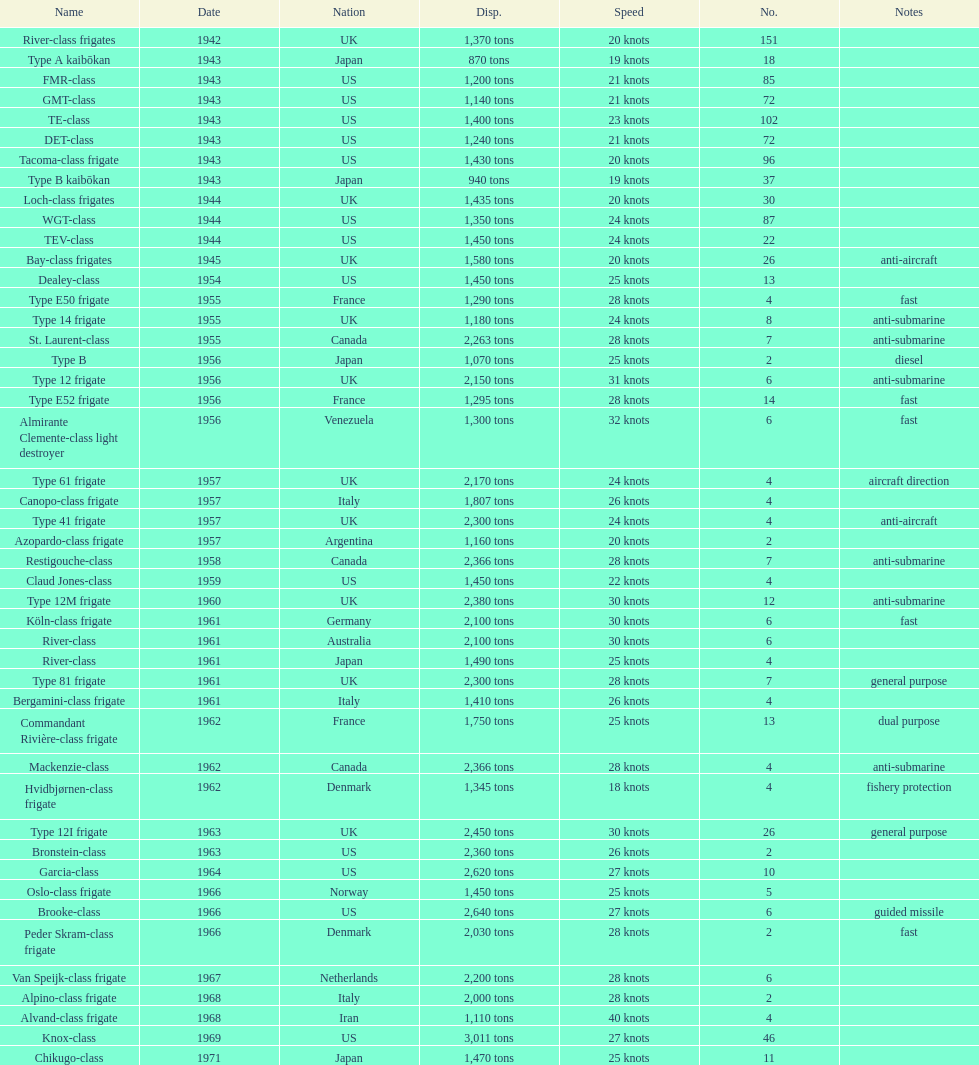Which of the boats listed is the fastest? Alvand-class frigate. Can you give me this table as a dict? {'header': ['Name', 'Date', 'Nation', 'Disp.', 'Speed', 'No.', 'Notes'], 'rows': [['River-class frigates', '1942', 'UK', '1,370 tons', '20 knots', '151', ''], ['Type A kaibōkan', '1943', 'Japan', '870 tons', '19 knots', '18', ''], ['FMR-class', '1943', 'US', '1,200 tons', '21 knots', '85', ''], ['GMT-class', '1943', 'US', '1,140 tons', '21 knots', '72', ''], ['TE-class', '1943', 'US', '1,400 tons', '23 knots', '102', ''], ['DET-class', '1943', 'US', '1,240 tons', '21 knots', '72', ''], ['Tacoma-class frigate', '1943', 'US', '1,430 tons', '20 knots', '96', ''], ['Type B kaibōkan', '1943', 'Japan', '940 tons', '19 knots', '37', ''], ['Loch-class frigates', '1944', 'UK', '1,435 tons', '20 knots', '30', ''], ['WGT-class', '1944', 'US', '1,350 tons', '24 knots', '87', ''], ['TEV-class', '1944', 'US', '1,450 tons', '24 knots', '22', ''], ['Bay-class frigates', '1945', 'UK', '1,580 tons', '20 knots', '26', 'anti-aircraft'], ['Dealey-class', '1954', 'US', '1,450 tons', '25 knots', '13', ''], ['Type E50 frigate', '1955', 'France', '1,290 tons', '28 knots', '4', 'fast'], ['Type 14 frigate', '1955', 'UK', '1,180 tons', '24 knots', '8', 'anti-submarine'], ['St. Laurent-class', '1955', 'Canada', '2,263 tons', '28 knots', '7', 'anti-submarine'], ['Type B', '1956', 'Japan', '1,070 tons', '25 knots', '2', 'diesel'], ['Type 12 frigate', '1956', 'UK', '2,150 tons', '31 knots', '6', 'anti-submarine'], ['Type E52 frigate', '1956', 'France', '1,295 tons', '28 knots', '14', 'fast'], ['Almirante Clemente-class light destroyer', '1956', 'Venezuela', '1,300 tons', '32 knots', '6', 'fast'], ['Type 61 frigate', '1957', 'UK', '2,170 tons', '24 knots', '4', 'aircraft direction'], ['Canopo-class frigate', '1957', 'Italy', '1,807 tons', '26 knots', '4', ''], ['Type 41 frigate', '1957', 'UK', '2,300 tons', '24 knots', '4', 'anti-aircraft'], ['Azopardo-class frigate', '1957', 'Argentina', '1,160 tons', '20 knots', '2', ''], ['Restigouche-class', '1958', 'Canada', '2,366 tons', '28 knots', '7', 'anti-submarine'], ['Claud Jones-class', '1959', 'US', '1,450 tons', '22 knots', '4', ''], ['Type 12M frigate', '1960', 'UK', '2,380 tons', '30 knots', '12', 'anti-submarine'], ['Köln-class frigate', '1961', 'Germany', '2,100 tons', '30 knots', '6', 'fast'], ['River-class', '1961', 'Australia', '2,100 tons', '30 knots', '6', ''], ['River-class', '1961', 'Japan', '1,490 tons', '25 knots', '4', ''], ['Type 81 frigate', '1961', 'UK', '2,300 tons', '28 knots', '7', 'general purpose'], ['Bergamini-class frigate', '1961', 'Italy', '1,410 tons', '26 knots', '4', ''], ['Commandant Rivière-class frigate', '1962', 'France', '1,750 tons', '25 knots', '13', 'dual purpose'], ['Mackenzie-class', '1962', 'Canada', '2,366 tons', '28 knots', '4', 'anti-submarine'], ['Hvidbjørnen-class frigate', '1962', 'Denmark', '1,345 tons', '18 knots', '4', 'fishery protection'], ['Type 12I frigate', '1963', 'UK', '2,450 tons', '30 knots', '26', 'general purpose'], ['Bronstein-class', '1963', 'US', '2,360 tons', '26 knots', '2', ''], ['Garcia-class', '1964', 'US', '2,620 tons', '27 knots', '10', ''], ['Oslo-class frigate', '1966', 'Norway', '1,450 tons', '25 knots', '5', ''], ['Brooke-class', '1966', 'US', '2,640 tons', '27 knots', '6', 'guided missile'], ['Peder Skram-class frigate', '1966', 'Denmark', '2,030 tons', '28 knots', '2', 'fast'], ['Van Speijk-class frigate', '1967', 'Netherlands', '2,200 tons', '28 knots', '6', ''], ['Alpino-class frigate', '1968', 'Italy', '2,000 tons', '28 knots', '2', ''], ['Alvand-class frigate', '1968', 'Iran', '1,110 tons', '40 knots', '4', ''], ['Knox-class', '1969', 'US', '3,011 tons', '27 knots', '46', ''], ['Chikugo-class', '1971', 'Japan', '1,470 tons', '25 knots', '11', '']]} 